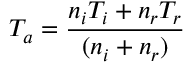Convert formula to latex. <formula><loc_0><loc_0><loc_500><loc_500>T _ { a } = \frac { n _ { i } T _ { i } + n _ { r } T _ { r } } { ( n _ { i } + n _ { r } ) }</formula> 